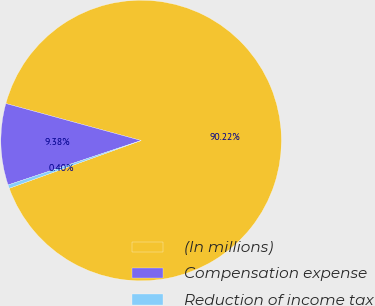<chart> <loc_0><loc_0><loc_500><loc_500><pie_chart><fcel>(In millions)<fcel>Compensation expense<fcel>Reduction of income tax<nl><fcel>90.21%<fcel>9.38%<fcel>0.4%<nl></chart> 